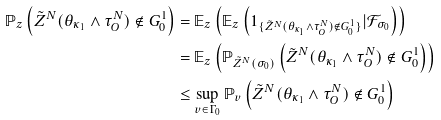<formula> <loc_0><loc_0><loc_500><loc_500>\mathbb { P } _ { z } \left ( \tilde { Z } ^ { N } ( \theta _ { \kappa _ { 1 } } \wedge \tau _ { O } ^ { N } ) \not \in G ^ { 1 } _ { 0 } \right ) & = \mathbb { E } _ { z } \left ( \mathbb { E } _ { z } \left ( 1 _ { \{ \tilde { Z } ^ { N } ( \theta _ { \kappa _ { 1 } } \wedge \tau _ { O } ^ { N } ) \not \in G ^ { 1 } _ { 0 } \} } | \mathcal { F } _ { \sigma _ { 0 } } \right ) \right ) \\ & = \mathbb { E } _ { z } \left ( \mathbb { P } _ { \tilde { Z } ^ { N } ( \sigma _ { 0 } ) } \left ( \tilde { Z } ^ { N } ( \theta _ { \kappa _ { 1 } } \wedge \tau _ { O } ^ { N } ) \not \in G ^ { 1 } _ { 0 } \right ) \right ) \\ & \leq \sup _ { v \in \Gamma _ { 0 } } \mathbb { P } _ { v } \left ( \tilde { Z } ^ { N } ( \theta _ { \kappa _ { 1 } } \wedge \tau _ { O } ^ { N } ) \not \in G ^ { 1 } _ { 0 } \right )</formula> 